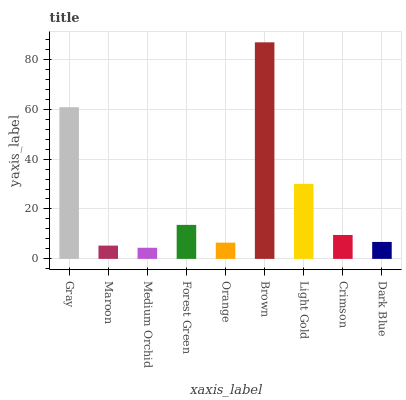Is Medium Orchid the minimum?
Answer yes or no. Yes. Is Brown the maximum?
Answer yes or no. Yes. Is Maroon the minimum?
Answer yes or no. No. Is Maroon the maximum?
Answer yes or no. No. Is Gray greater than Maroon?
Answer yes or no. Yes. Is Maroon less than Gray?
Answer yes or no. Yes. Is Maroon greater than Gray?
Answer yes or no. No. Is Gray less than Maroon?
Answer yes or no. No. Is Crimson the high median?
Answer yes or no. Yes. Is Crimson the low median?
Answer yes or no. Yes. Is Light Gold the high median?
Answer yes or no. No. Is Medium Orchid the low median?
Answer yes or no. No. 